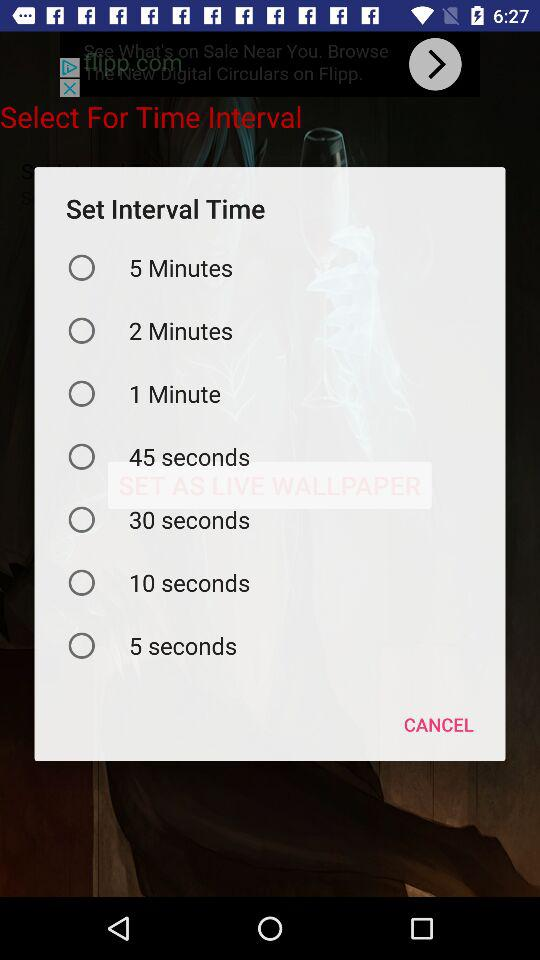How many seconds are there in the longest interval?
Answer the question using a single word or phrase. 300 